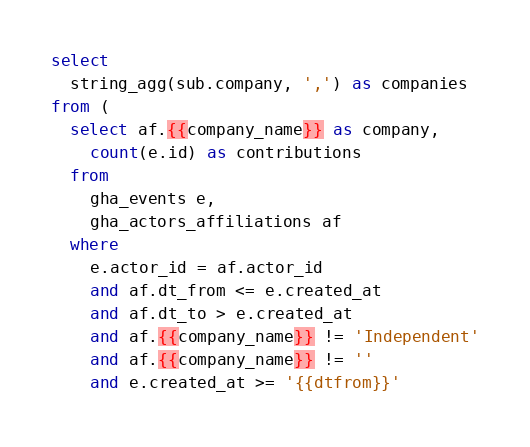<code> <loc_0><loc_0><loc_500><loc_500><_SQL_>select
  string_agg(sub.company, ',') as companies
from (
  select af.{{company_name}} as company,
    count(e.id) as contributions
  from
    gha_events e,
    gha_actors_affiliations af
  where
    e.actor_id = af.actor_id
    and af.dt_from <= e.created_at
    and af.dt_to > e.created_at
    and af.{{company_name}} != 'Independent'
    and af.{{company_name}} != ''
    and e.created_at >= '{{dtfrom}}'</code> 